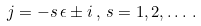Convert formula to latex. <formula><loc_0><loc_0><loc_500><loc_500>j = - s \, \epsilon \pm i \, , \, s = 1 , 2 , \dots \, .</formula> 